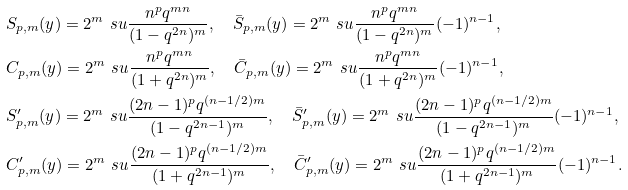<formula> <loc_0><loc_0><loc_500><loc_500>& S _ { p , m } ( y ) = 2 ^ { m } \ s u \frac { n ^ { p } q ^ { m n } } { ( 1 - q ^ { 2 n } ) ^ { m } } , \quad \bar { S } _ { p , m } ( y ) = 2 ^ { m } \ s u \frac { n ^ { p } q ^ { m n } } { ( 1 - q ^ { 2 n } ) ^ { m } } ( - 1 ) ^ { n - 1 } , \\ & C _ { p , m } ( y ) = 2 ^ { m } \ s u \frac { n ^ { p } q ^ { m n } } { ( 1 + q ^ { 2 n } ) ^ { m } } , \quad \bar { C } _ { p , m } ( y ) = 2 ^ { m } \ s u \frac { n ^ { p } q ^ { m n } } { ( 1 + q ^ { 2 n } ) ^ { m } } ( - 1 ) ^ { n - 1 } , \\ & S ^ { \prime } _ { p , m } ( y ) = 2 ^ { m } \ s u \frac { ( 2 n - 1 ) ^ { p } q ^ { ( n - 1 / 2 ) m } } { ( 1 - q ^ { 2 n - 1 } ) ^ { m } } , \quad \bar { S } ^ { \prime } _ { p , m } ( y ) = 2 ^ { m } \ s u \frac { ( 2 n - 1 ) ^ { p } q ^ { ( n - 1 / 2 ) m } } { ( 1 - q ^ { 2 n - 1 } ) ^ { m } } ( - 1 ) ^ { n - 1 } , \\ & C ^ { \prime } _ { p , m } ( y ) = 2 ^ { m } \ s u \frac { ( 2 n - 1 ) ^ { p } q ^ { ( n - 1 / 2 ) m } } { ( 1 + q ^ { 2 n - 1 } ) ^ { m } } , \quad \bar { C } ^ { \prime } _ { p , m } ( y ) = 2 ^ { m } \ s u \frac { ( 2 n - 1 ) ^ { p } q ^ { ( n - 1 / 2 ) m } } { ( 1 + q ^ { 2 n - 1 } ) ^ { m } } ( - 1 ) ^ { n - 1 } .</formula> 